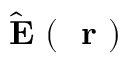<formula> <loc_0><loc_0><loc_500><loc_500>\hat { E } ( r )</formula> 